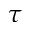Convert formula to latex. <formula><loc_0><loc_0><loc_500><loc_500>\tau</formula> 